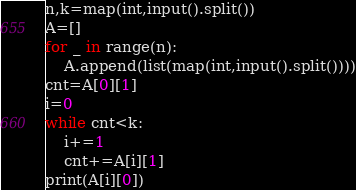Convert code to text. <code><loc_0><loc_0><loc_500><loc_500><_Python_>n,k=map(int,input().split())
A=[]
for _ in range(n):
    A.append(list(map(int,input().split())))
cnt=A[0][1]
i=0
while cnt<k:
    i+=1
    cnt+=A[i][1]
print(A[i][0])</code> 